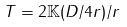<formula> <loc_0><loc_0><loc_500><loc_500>T = 2 { \mathbb { K } } ( D / 4 r ) / r</formula> 